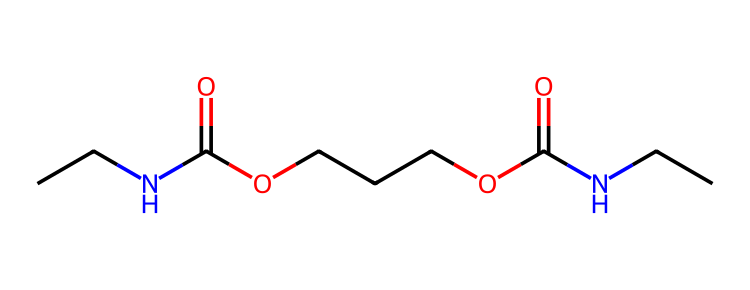how many nitrogen atoms are present in this chemical? By inspecting the SMILES representation, we can see the segments "NCC" and "NCC" indicating the presence of nitrogen atoms. In total, there are two nitrogen atoms in the chemical.
Answer: two what is the main functional group observed in this chemical? The chemical contains multiple segments that denote functional groups, specifically there are "C(=O)O" segments which indicate the presence of carboxylic acid groups. Therefore, the main functional group observed is the carboxylic acid.
Answer: carboxylic acid how many total carbon atoms are in this chemical? To determine the number of carbon atoms, we count the occurrences of "C" throughout the entire SMILES. There are seven instances of carbon in the provided structure.
Answer: seven what type of solid is this chemical likely to form? Given the presence of nitrogen, carbon, and functional groups like carboxylic acids, this chemical would probably form an organic polymer solid known for its flexibility and durability.
Answer: polymer how does the presence of nitrogen influence the properties of this solid? Nitrogen contributes to the formation of amine and amide functionalities, which can improve the material's flexibility and reduce brittleness. Thus, nitrogen enhances the overall mechanical properties of the solid.
Answer: flexibility is this chemical hydrophilic or hydrophobic? The presence of carboxylic acid groups suggests that this chemical would be hydrophilic due to its ability to form hydrogen bonds with water, leading to better solubility in polar solvents.
Answer: hydrophilic what is the total number of oxygen atoms in the chemical? In the SMILES representation, we can identify two occurrences of "O" from the carboxylic acid groups, indicating a total of four oxygen atoms present in the chemical's structure.
Answer: four 